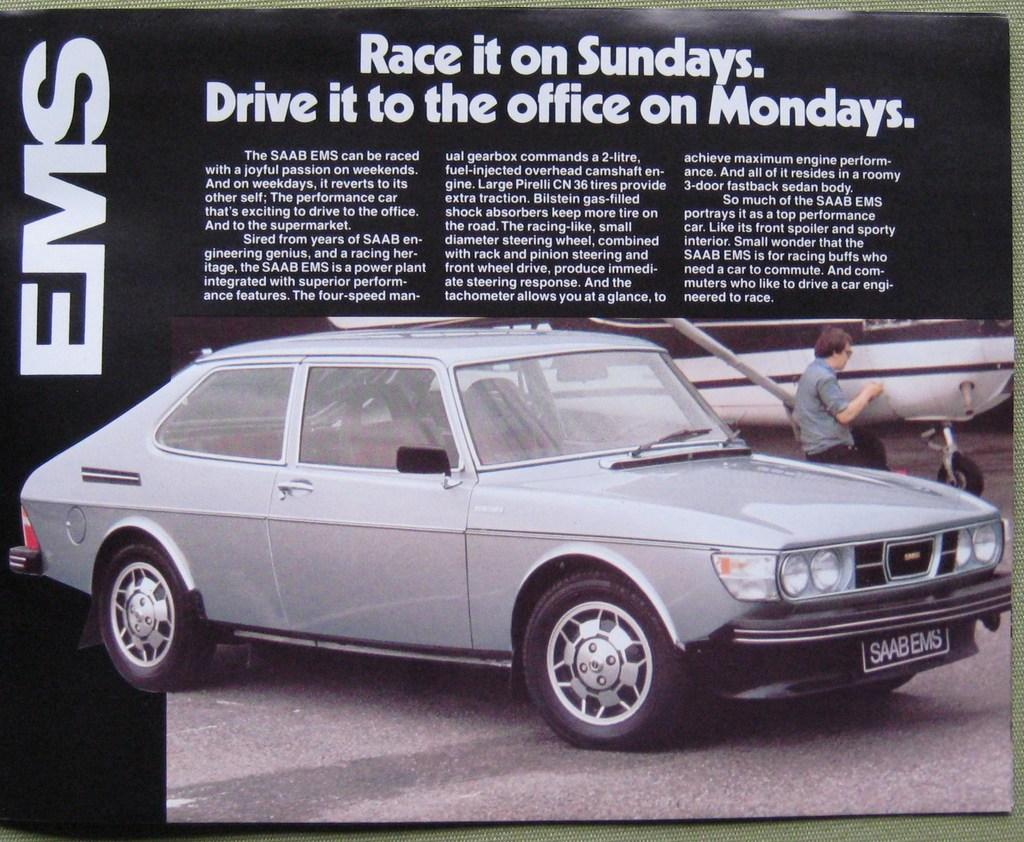What is the main subject of the image? There is a car in the image. Are there any words or letters in the image? Yes, there is some text in the image. What is the person in the image doing? The person is standing in front of an airplane. Where is the airplane located in the image? The airplane is on the right side of the image. What type of wealth is displayed on the table in the image? There is no table or any indication of wealth present in the image. How many gloves can be seen on the person in the image? There is no person wearing gloves in the image. 